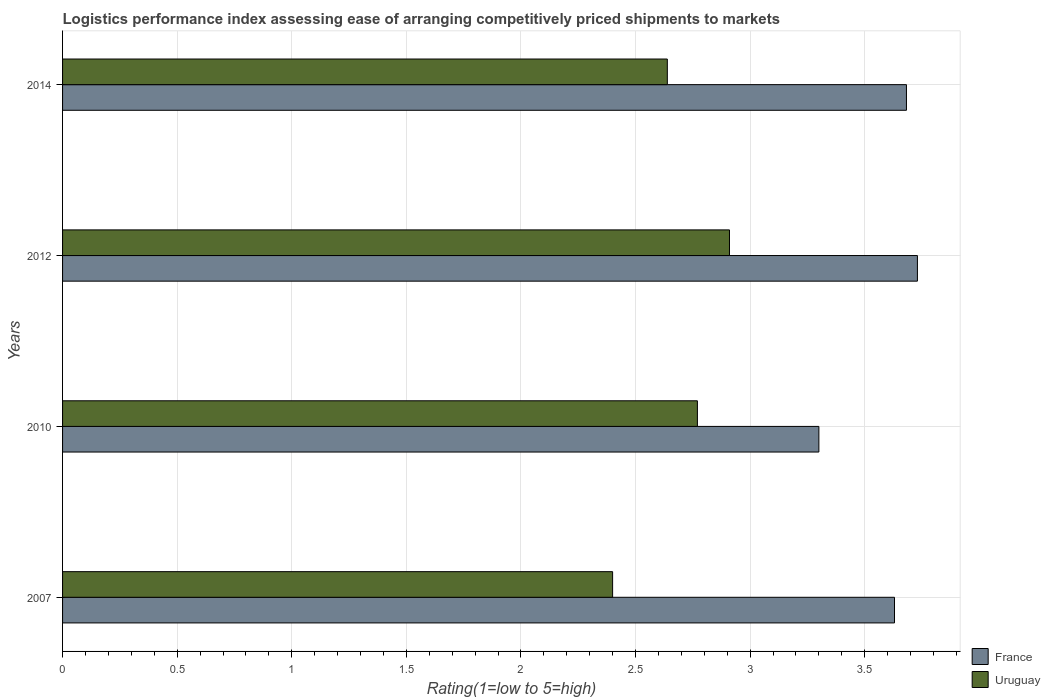How many different coloured bars are there?
Make the answer very short. 2. How many groups of bars are there?
Your answer should be very brief. 4. Are the number of bars per tick equal to the number of legend labels?
Offer a terse response. Yes. Are the number of bars on each tick of the Y-axis equal?
Give a very brief answer. Yes. What is the label of the 4th group of bars from the top?
Your answer should be very brief. 2007. What is the Logistic performance index in France in 2007?
Give a very brief answer. 3.63. Across all years, what is the maximum Logistic performance index in France?
Your response must be concise. 3.73. In which year was the Logistic performance index in France maximum?
Offer a very short reply. 2012. What is the total Logistic performance index in Uruguay in the graph?
Provide a succinct answer. 10.72. What is the difference between the Logistic performance index in France in 2010 and that in 2012?
Ensure brevity in your answer.  -0.43. What is the difference between the Logistic performance index in France in 2014 and the Logistic performance index in Uruguay in 2012?
Offer a terse response. 0.77. What is the average Logistic performance index in Uruguay per year?
Your answer should be compact. 2.68. In the year 2014, what is the difference between the Logistic performance index in France and Logistic performance index in Uruguay?
Give a very brief answer. 1.04. In how many years, is the Logistic performance index in Uruguay greater than 0.9 ?
Provide a short and direct response. 4. What is the ratio of the Logistic performance index in France in 2007 to that in 2012?
Give a very brief answer. 0.97. Is the difference between the Logistic performance index in France in 2007 and 2010 greater than the difference between the Logistic performance index in Uruguay in 2007 and 2010?
Your answer should be very brief. Yes. What is the difference between the highest and the second highest Logistic performance index in Uruguay?
Your response must be concise. 0.14. What is the difference between the highest and the lowest Logistic performance index in France?
Your answer should be compact. 0.43. What does the 2nd bar from the top in 2014 represents?
Your answer should be compact. France. What does the 2nd bar from the bottom in 2010 represents?
Your answer should be compact. Uruguay. How many bars are there?
Keep it short and to the point. 8. Are the values on the major ticks of X-axis written in scientific E-notation?
Your response must be concise. No. Does the graph contain any zero values?
Offer a terse response. No. Where does the legend appear in the graph?
Provide a succinct answer. Bottom right. How are the legend labels stacked?
Your response must be concise. Vertical. What is the title of the graph?
Your answer should be very brief. Logistics performance index assessing ease of arranging competitively priced shipments to markets. Does "Fragile and conflict affected situations" appear as one of the legend labels in the graph?
Your answer should be very brief. No. What is the label or title of the X-axis?
Provide a succinct answer. Rating(1=low to 5=high). What is the Rating(1=low to 5=high) in France in 2007?
Make the answer very short. 3.63. What is the Rating(1=low to 5=high) of Uruguay in 2007?
Make the answer very short. 2.4. What is the Rating(1=low to 5=high) of Uruguay in 2010?
Offer a terse response. 2.77. What is the Rating(1=low to 5=high) of France in 2012?
Provide a succinct answer. 3.73. What is the Rating(1=low to 5=high) of Uruguay in 2012?
Provide a succinct answer. 2.91. What is the Rating(1=low to 5=high) of France in 2014?
Provide a short and direct response. 3.68. What is the Rating(1=low to 5=high) in Uruguay in 2014?
Ensure brevity in your answer.  2.64. Across all years, what is the maximum Rating(1=low to 5=high) of France?
Provide a succinct answer. 3.73. Across all years, what is the maximum Rating(1=low to 5=high) in Uruguay?
Your answer should be very brief. 2.91. Across all years, what is the minimum Rating(1=low to 5=high) in France?
Your response must be concise. 3.3. Across all years, what is the minimum Rating(1=low to 5=high) of Uruguay?
Make the answer very short. 2.4. What is the total Rating(1=low to 5=high) of France in the graph?
Your response must be concise. 14.34. What is the total Rating(1=low to 5=high) of Uruguay in the graph?
Keep it short and to the point. 10.72. What is the difference between the Rating(1=low to 5=high) of France in 2007 and that in 2010?
Provide a succinct answer. 0.33. What is the difference between the Rating(1=low to 5=high) of Uruguay in 2007 and that in 2010?
Give a very brief answer. -0.37. What is the difference between the Rating(1=low to 5=high) in France in 2007 and that in 2012?
Ensure brevity in your answer.  -0.1. What is the difference between the Rating(1=low to 5=high) of Uruguay in 2007 and that in 2012?
Your answer should be compact. -0.51. What is the difference between the Rating(1=low to 5=high) of France in 2007 and that in 2014?
Provide a short and direct response. -0.05. What is the difference between the Rating(1=low to 5=high) of Uruguay in 2007 and that in 2014?
Ensure brevity in your answer.  -0.24. What is the difference between the Rating(1=low to 5=high) of France in 2010 and that in 2012?
Your answer should be compact. -0.43. What is the difference between the Rating(1=low to 5=high) of Uruguay in 2010 and that in 2012?
Provide a succinct answer. -0.14. What is the difference between the Rating(1=low to 5=high) in France in 2010 and that in 2014?
Make the answer very short. -0.38. What is the difference between the Rating(1=low to 5=high) in Uruguay in 2010 and that in 2014?
Provide a succinct answer. 0.13. What is the difference between the Rating(1=low to 5=high) of France in 2012 and that in 2014?
Provide a succinct answer. 0.05. What is the difference between the Rating(1=low to 5=high) of Uruguay in 2012 and that in 2014?
Give a very brief answer. 0.27. What is the difference between the Rating(1=low to 5=high) of France in 2007 and the Rating(1=low to 5=high) of Uruguay in 2010?
Offer a terse response. 0.86. What is the difference between the Rating(1=low to 5=high) in France in 2007 and the Rating(1=low to 5=high) in Uruguay in 2012?
Offer a terse response. 0.72. What is the difference between the Rating(1=low to 5=high) in France in 2007 and the Rating(1=low to 5=high) in Uruguay in 2014?
Offer a terse response. 0.99. What is the difference between the Rating(1=low to 5=high) of France in 2010 and the Rating(1=low to 5=high) of Uruguay in 2012?
Offer a very short reply. 0.39. What is the difference between the Rating(1=low to 5=high) of France in 2010 and the Rating(1=low to 5=high) of Uruguay in 2014?
Make the answer very short. 0.66. What is the difference between the Rating(1=low to 5=high) in France in 2012 and the Rating(1=low to 5=high) in Uruguay in 2014?
Offer a very short reply. 1.09. What is the average Rating(1=low to 5=high) in France per year?
Make the answer very short. 3.59. What is the average Rating(1=low to 5=high) in Uruguay per year?
Your response must be concise. 2.68. In the year 2007, what is the difference between the Rating(1=low to 5=high) of France and Rating(1=low to 5=high) of Uruguay?
Offer a very short reply. 1.23. In the year 2010, what is the difference between the Rating(1=low to 5=high) of France and Rating(1=low to 5=high) of Uruguay?
Provide a succinct answer. 0.53. In the year 2012, what is the difference between the Rating(1=low to 5=high) of France and Rating(1=low to 5=high) of Uruguay?
Give a very brief answer. 0.82. In the year 2014, what is the difference between the Rating(1=low to 5=high) of France and Rating(1=low to 5=high) of Uruguay?
Make the answer very short. 1.04. What is the ratio of the Rating(1=low to 5=high) in France in 2007 to that in 2010?
Give a very brief answer. 1.1. What is the ratio of the Rating(1=low to 5=high) in Uruguay in 2007 to that in 2010?
Make the answer very short. 0.87. What is the ratio of the Rating(1=low to 5=high) of France in 2007 to that in 2012?
Offer a terse response. 0.97. What is the ratio of the Rating(1=low to 5=high) in Uruguay in 2007 to that in 2012?
Ensure brevity in your answer.  0.82. What is the ratio of the Rating(1=low to 5=high) in France in 2007 to that in 2014?
Ensure brevity in your answer.  0.99. What is the ratio of the Rating(1=low to 5=high) of Uruguay in 2007 to that in 2014?
Make the answer very short. 0.91. What is the ratio of the Rating(1=low to 5=high) in France in 2010 to that in 2012?
Ensure brevity in your answer.  0.88. What is the ratio of the Rating(1=low to 5=high) of Uruguay in 2010 to that in 2012?
Offer a terse response. 0.95. What is the ratio of the Rating(1=low to 5=high) of France in 2010 to that in 2014?
Make the answer very short. 0.9. What is the ratio of the Rating(1=low to 5=high) in Uruguay in 2010 to that in 2014?
Keep it short and to the point. 1.05. What is the ratio of the Rating(1=low to 5=high) of France in 2012 to that in 2014?
Make the answer very short. 1.01. What is the ratio of the Rating(1=low to 5=high) in Uruguay in 2012 to that in 2014?
Your answer should be very brief. 1.1. What is the difference between the highest and the second highest Rating(1=low to 5=high) of France?
Offer a terse response. 0.05. What is the difference between the highest and the second highest Rating(1=low to 5=high) in Uruguay?
Make the answer very short. 0.14. What is the difference between the highest and the lowest Rating(1=low to 5=high) of France?
Give a very brief answer. 0.43. What is the difference between the highest and the lowest Rating(1=low to 5=high) of Uruguay?
Provide a succinct answer. 0.51. 